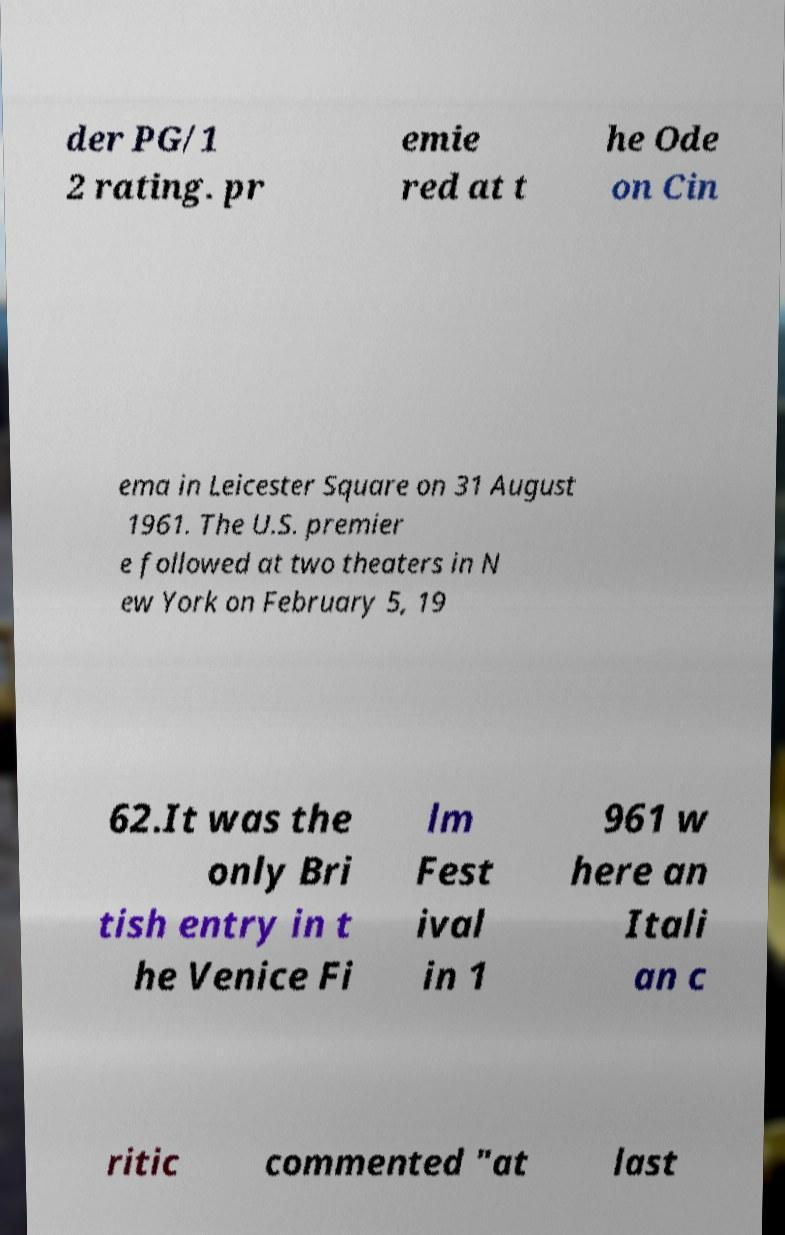Please identify and transcribe the text found in this image. der PG/1 2 rating. pr emie red at t he Ode on Cin ema in Leicester Square on 31 August 1961. The U.S. premier e followed at two theaters in N ew York on February 5, 19 62.It was the only Bri tish entry in t he Venice Fi lm Fest ival in 1 961 w here an Itali an c ritic commented "at last 